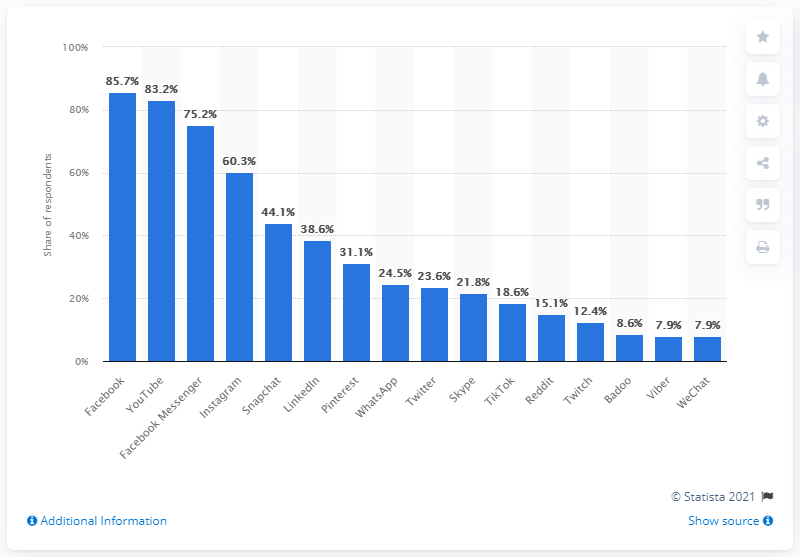Identify some key points in this picture. According to the information provided, YouTube was the second most popular social network in Denmark. 